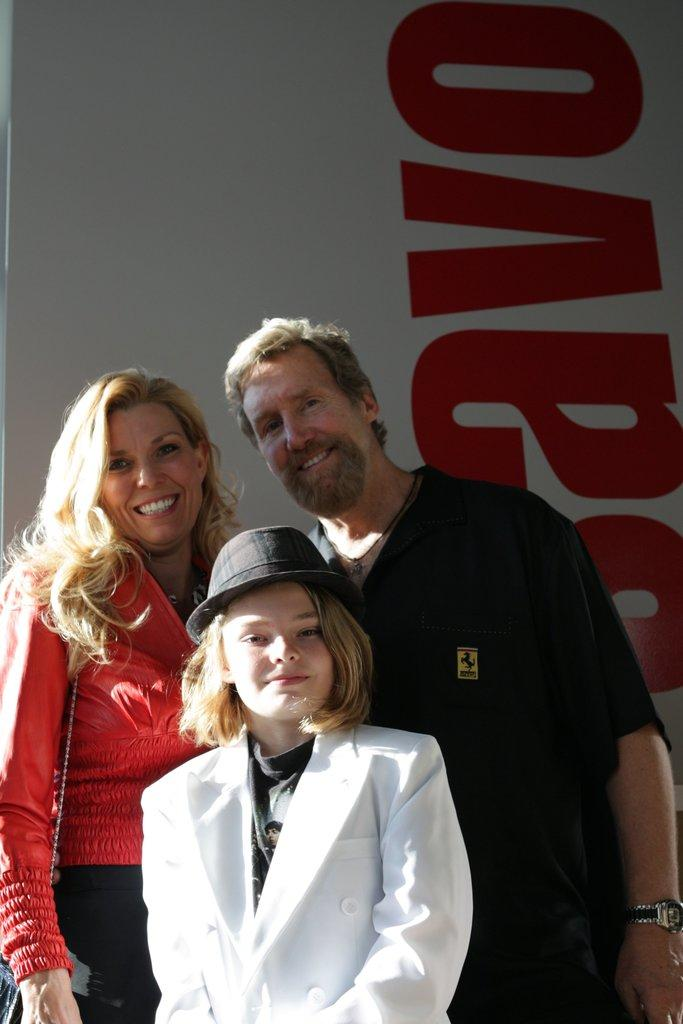How many people are in the image? There are three persons in the image. What colors are the dresses worn by the persons? One person is wearing a white dress, one person is wearing a black dress, and one person is wearing a red dress. What are the persons doing in the image? The persons are standing. What colors can be seen in the background of the image? The background of the image has a white and red color. Can you tell me how many kittens are sitting on the branch in the image? There is no branch or kittens present in the image. What type of account does the person in the red dress have in the image? There is no mention of an account in the image; it only shows three persons standing in front of a colored background. 